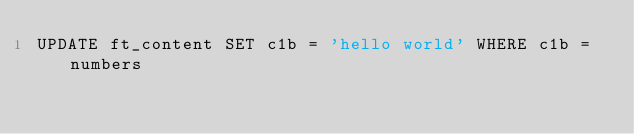Convert code to text. <code><loc_0><loc_0><loc_500><loc_500><_SQL_>UPDATE ft_content SET c1b = 'hello world' WHERE c1b = numbers
</code> 